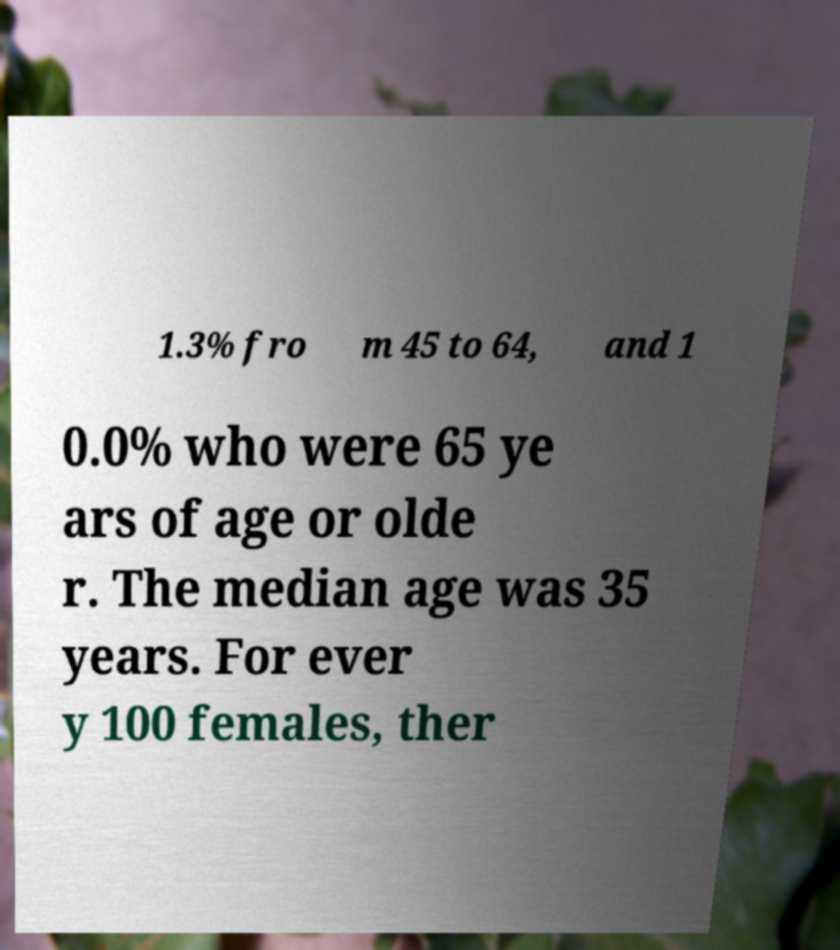For documentation purposes, I need the text within this image transcribed. Could you provide that? 1.3% fro m 45 to 64, and 1 0.0% who were 65 ye ars of age or olde r. The median age was 35 years. For ever y 100 females, ther 